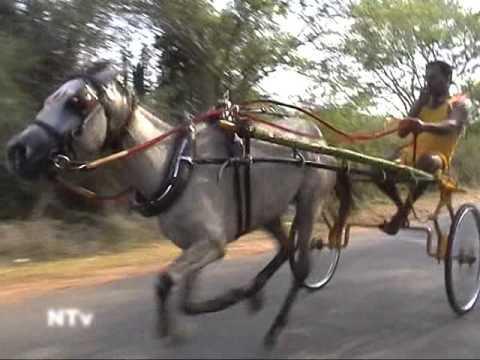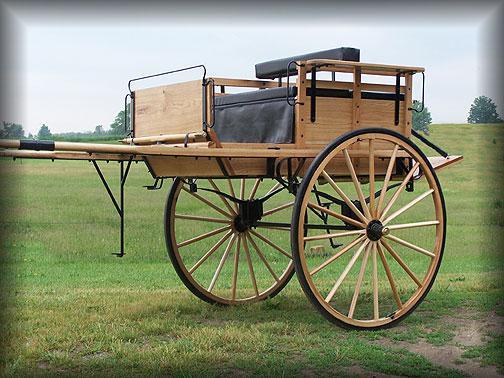The first image is the image on the left, the second image is the image on the right. Considering the images on both sides, is "At least one horse is white." valid? Answer yes or no. Yes. 